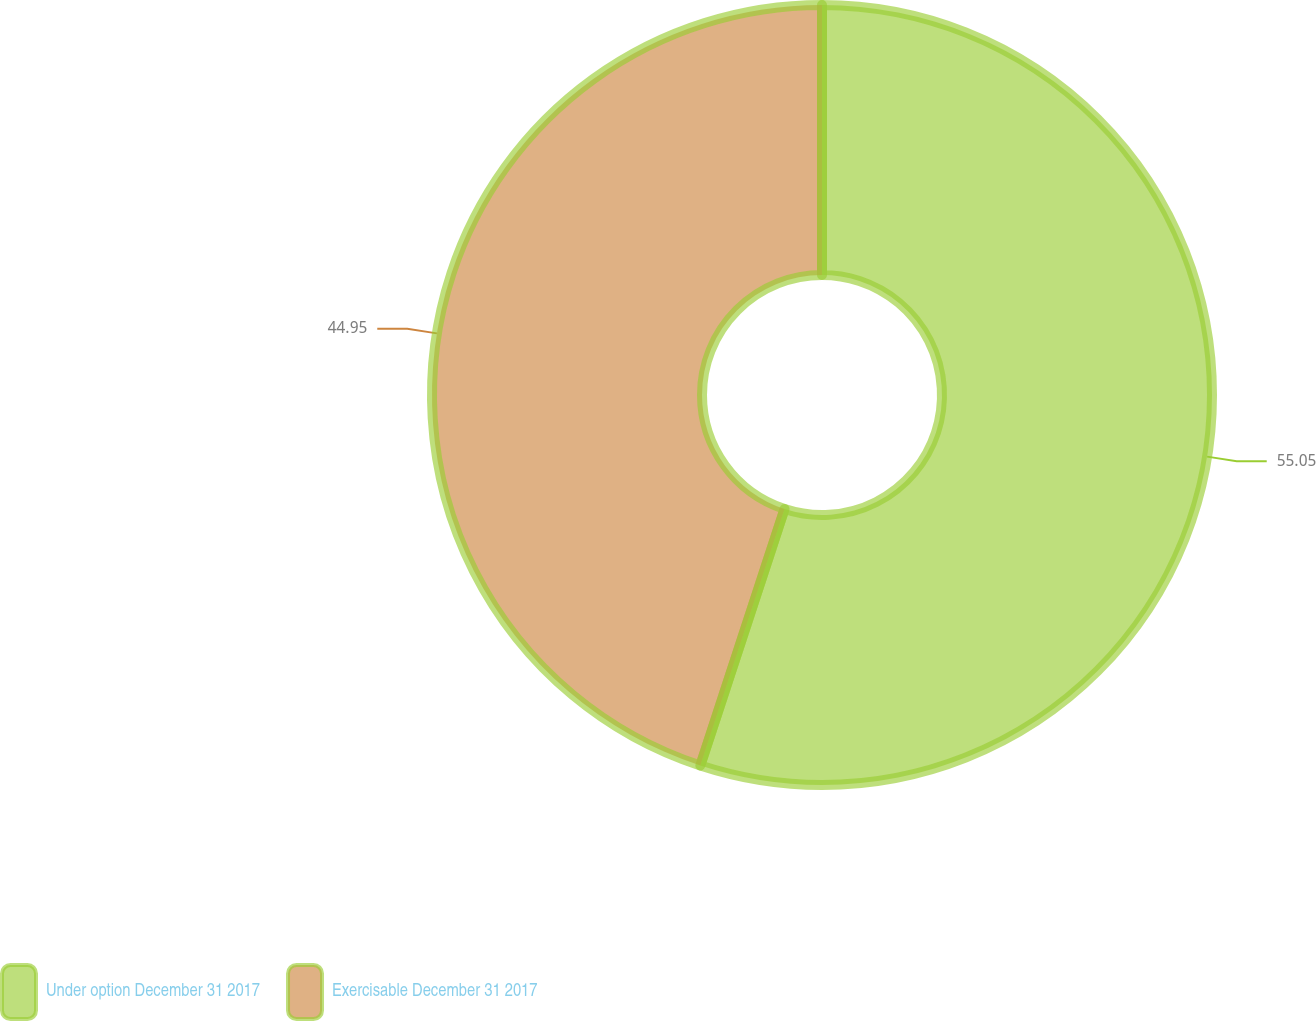<chart> <loc_0><loc_0><loc_500><loc_500><pie_chart><fcel>Under option December 31 2017<fcel>Exercisable December 31 2017<nl><fcel>55.05%<fcel>44.95%<nl></chart> 